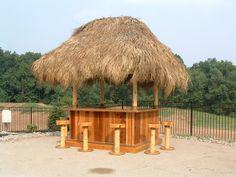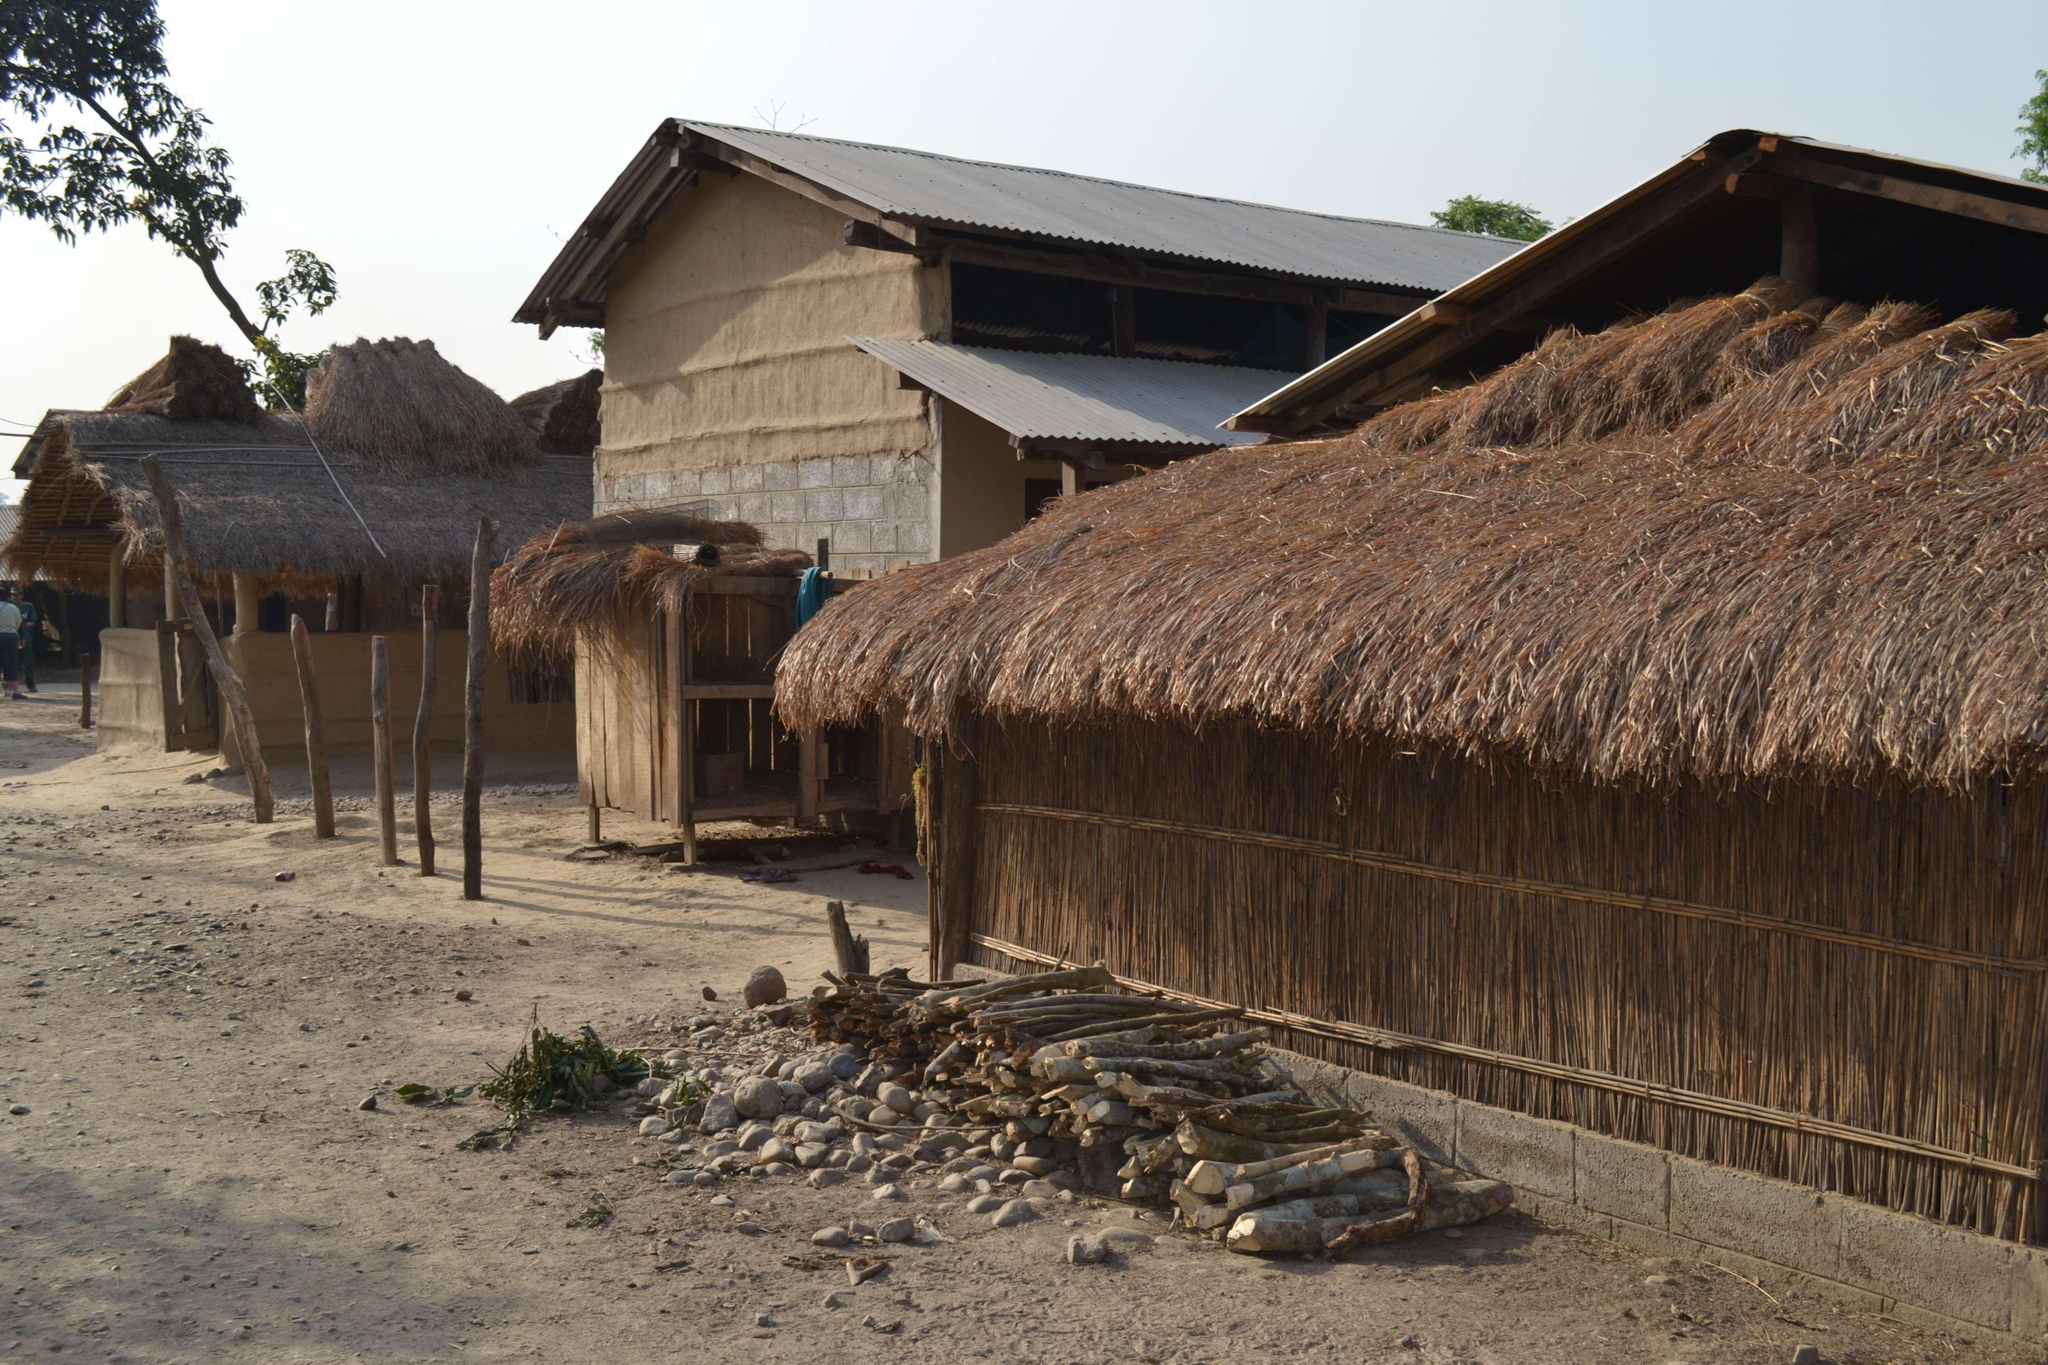The first image is the image on the left, the second image is the image on the right. Examine the images to the left and right. Is the description "A person is standing outside near a building in one of the images." accurate? Answer yes or no. No. The first image is the image on the left, the second image is the image on the right. For the images shown, is this caption "The right image shows several low round buildings with cone-shaped roofs in an area with brown dirt instead of grass." true? Answer yes or no. No. 